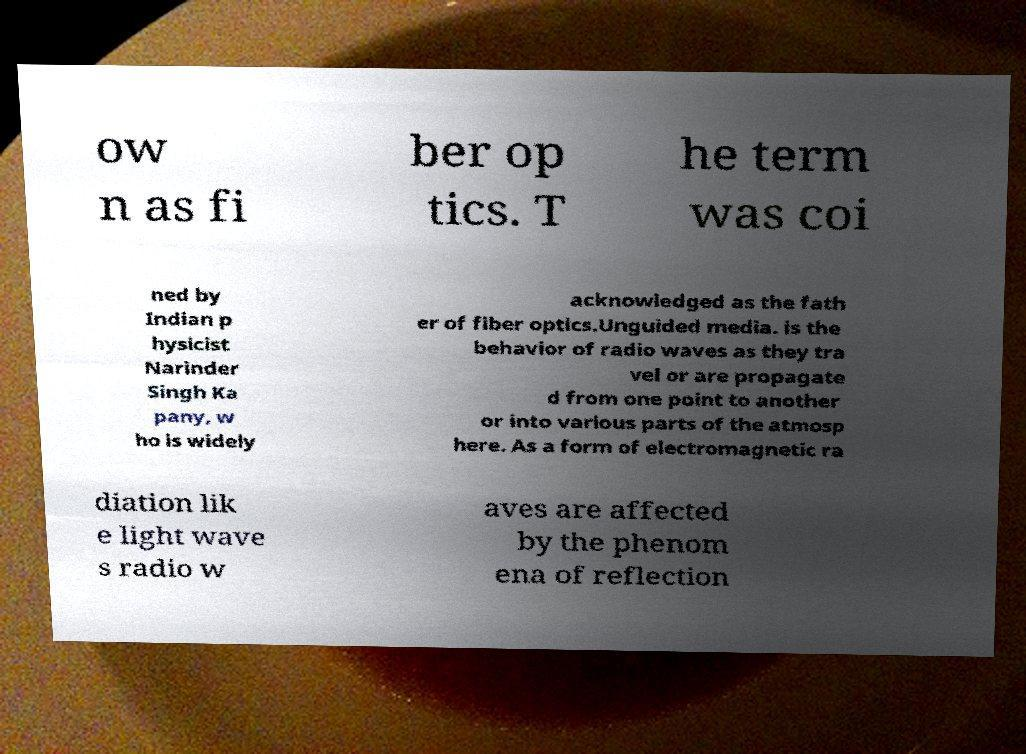Can you accurately transcribe the text from the provided image for me? ow n as fi ber op tics. T he term was coi ned by Indian p hysicist Narinder Singh Ka pany, w ho is widely acknowledged as the fath er of fiber optics.Unguided media. is the behavior of radio waves as they tra vel or are propagate d from one point to another or into various parts of the atmosp here. As a form of electromagnetic ra diation lik e light wave s radio w aves are affected by the phenom ena of reflection 